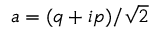Convert formula to latex. <formula><loc_0><loc_0><loc_500><loc_500>a = ( q + i p ) / \sqrt { 2 }</formula> 